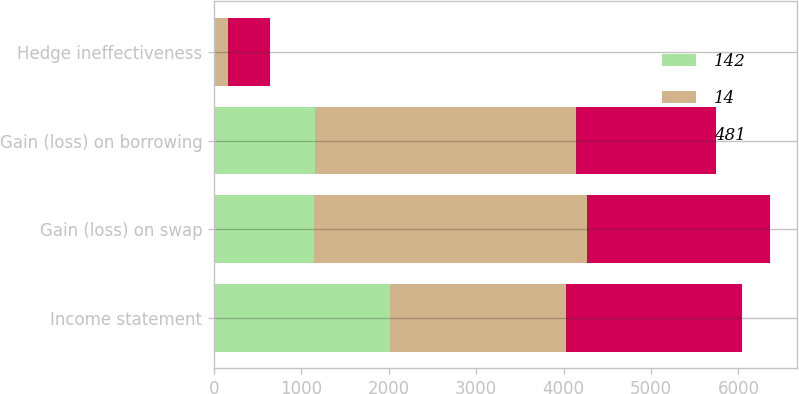<chart> <loc_0><loc_0><loc_500><loc_500><stacked_bar_chart><ecel><fcel>Income statement<fcel>Gain (loss) on swap<fcel>Gain (loss) on borrowing<fcel>Hedge ineffectiveness<nl><fcel>142<fcel>2014<fcel>1140<fcel>1154<fcel>14<nl><fcel>14<fcel>2013<fcel>3133<fcel>2991<fcel>142<nl><fcel>481<fcel>2012<fcel>2085<fcel>1604<fcel>481<nl></chart> 